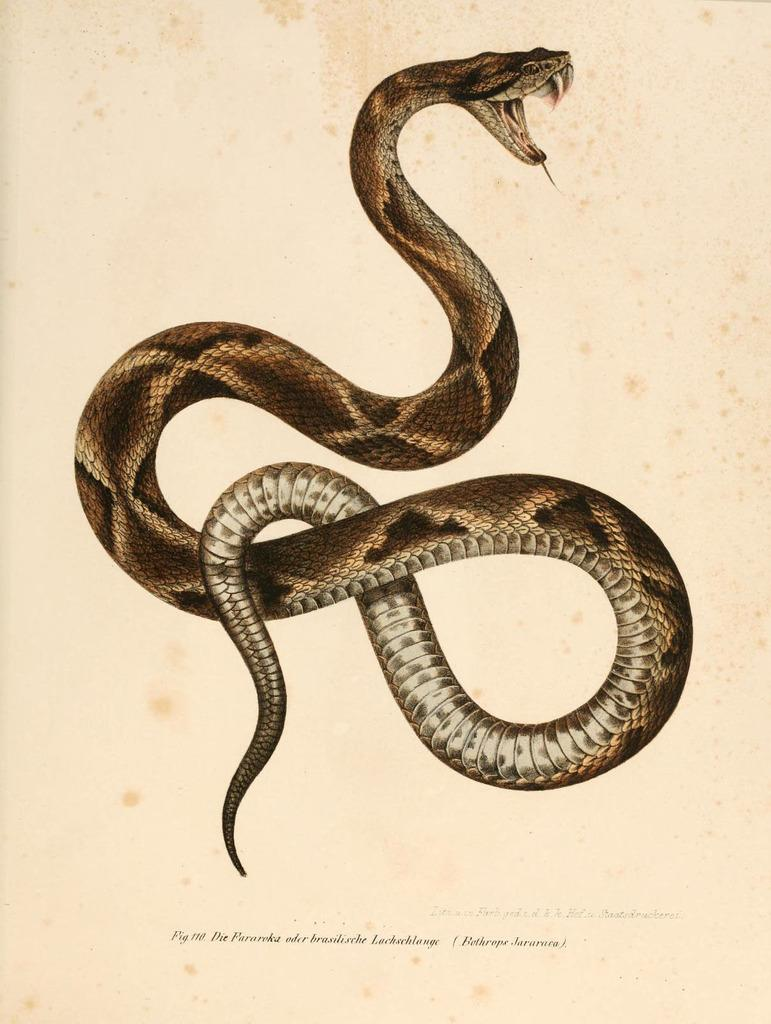What is the main subject of the image? The main subject of the image is a picture of a snake. Is there any text associated with the image? Yes, there is text at the bottom of the image. Where can the store selling straw and lettuce be found in the image? There is no store, straw, or lettuce present in the image. 